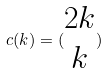Convert formula to latex. <formula><loc_0><loc_0><loc_500><loc_500>c ( k ) = ( \begin{matrix} 2 k \\ k \end{matrix} )</formula> 